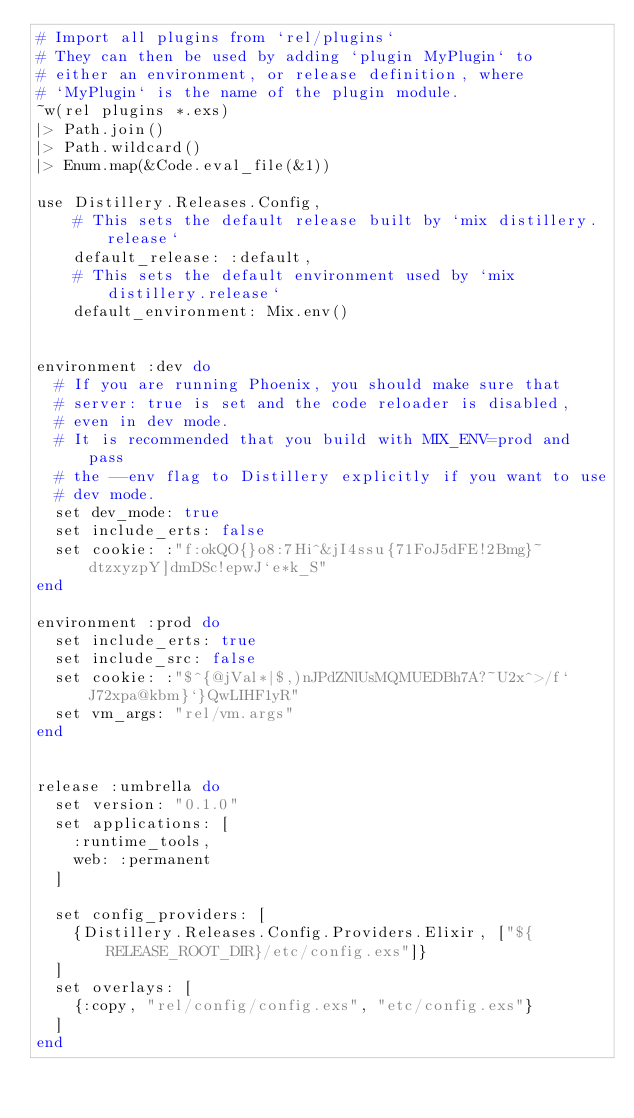Convert code to text. <code><loc_0><loc_0><loc_500><loc_500><_Elixir_># Import all plugins from `rel/plugins`
# They can then be used by adding `plugin MyPlugin` to
# either an environment, or release definition, where
# `MyPlugin` is the name of the plugin module.
~w(rel plugins *.exs)
|> Path.join()
|> Path.wildcard()
|> Enum.map(&Code.eval_file(&1))

use Distillery.Releases.Config,
    # This sets the default release built by `mix distillery.release`
    default_release: :default,
    # This sets the default environment used by `mix distillery.release`
    default_environment: Mix.env()


environment :dev do
  # If you are running Phoenix, you should make sure that
  # server: true is set and the code reloader is disabled,
  # even in dev mode.
  # It is recommended that you build with MIX_ENV=prod and pass
  # the --env flag to Distillery explicitly if you want to use
  # dev mode.
  set dev_mode: true
  set include_erts: false
  set cookie: :"f:okQO{}o8:7Hi^&jI4ssu{71FoJ5dFE!2Bmg}~dtzxyzpY]dmDSc!epwJ`e*k_S"
end

environment :prod do
  set include_erts: true
  set include_src: false
  set cookie: :"$^{@jVal*|$,)nJPdZNlUsMQMUEDBh7A?~U2x^>/f`J72xpa@kbm}`}QwLIHF1yR"
  set vm_args: "rel/vm.args"
end


release :umbrella do
  set version: "0.1.0"
  set applications: [
    :runtime_tools,
    web: :permanent
  ]

  set config_providers: [
    {Distillery.Releases.Config.Providers.Elixir, ["${RELEASE_ROOT_DIR}/etc/config.exs"]}
  ]
  set overlays: [
    {:copy, "rel/config/config.exs", "etc/config.exs"}
  ]
end

</code> 